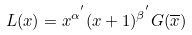<formula> <loc_0><loc_0><loc_500><loc_500>L ( x ) = x ^ { \alpha ^ { ^ { \prime } } } ( x + 1 ) ^ { \beta ^ { ^ { \prime } } } G ( \overline { x } )</formula> 